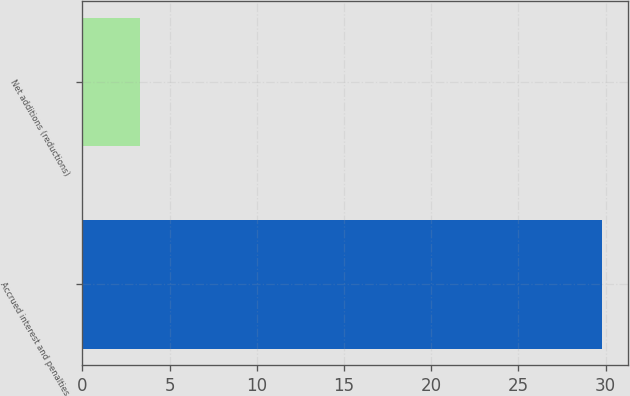<chart> <loc_0><loc_0><loc_500><loc_500><bar_chart><fcel>Accrued interest and penalties<fcel>Net additions (reductions)<nl><fcel>29.8<fcel>3.3<nl></chart> 